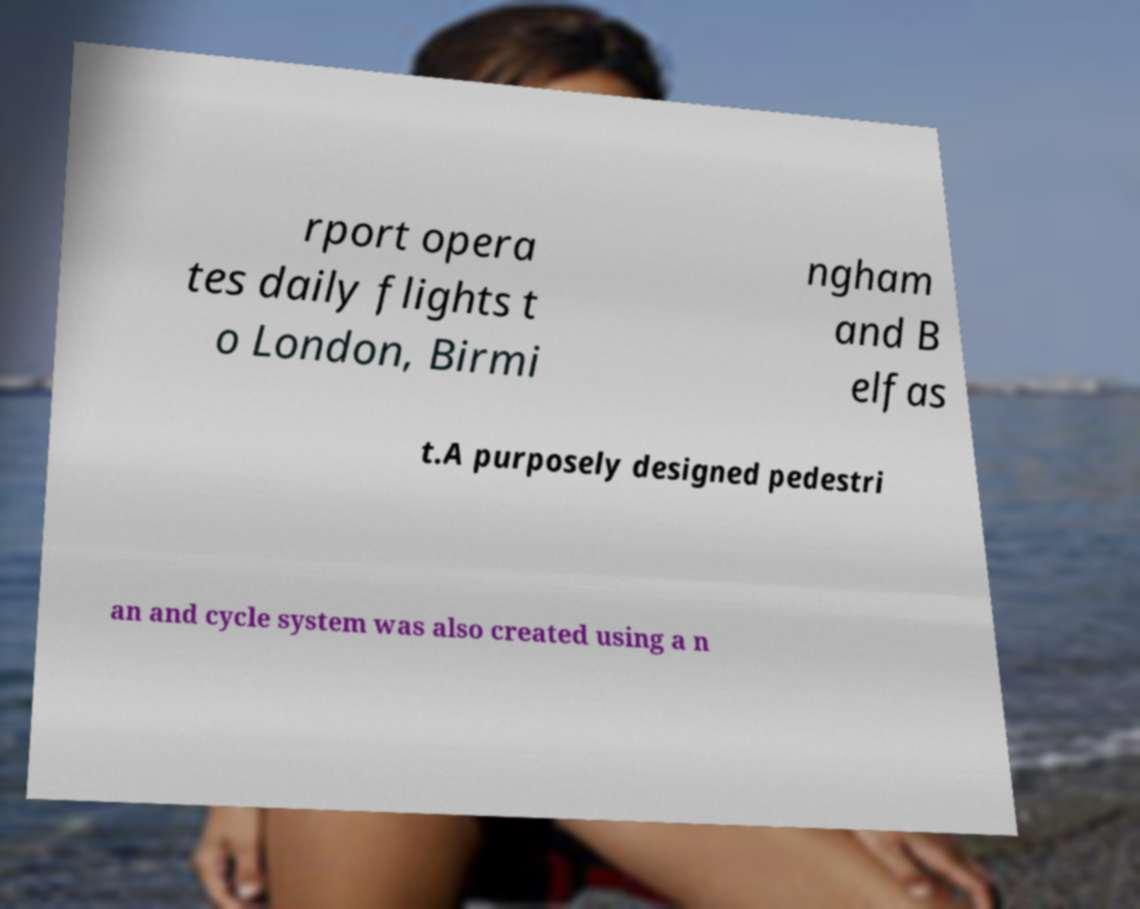Please identify and transcribe the text found in this image. rport opera tes daily flights t o London, Birmi ngham and B elfas t.A purposely designed pedestri an and cycle system was also created using a n 